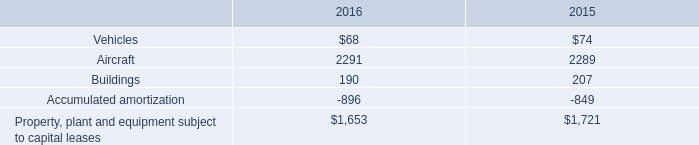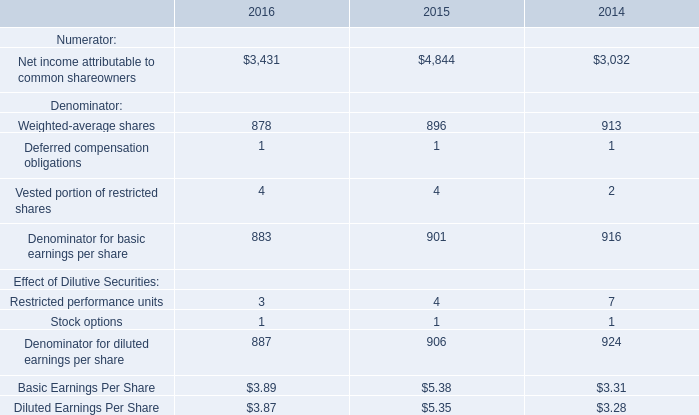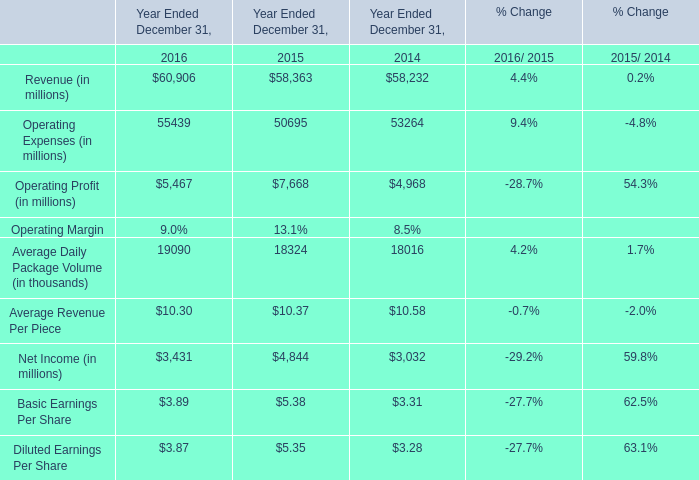What was the average value of the Average Daily Package Volume in the years where Revenue is positive for Year Ended December 31,? (in thousand) 
Computations: (((19090 + 18324) + 18016) / 3)
Answer: 18476.66667. 